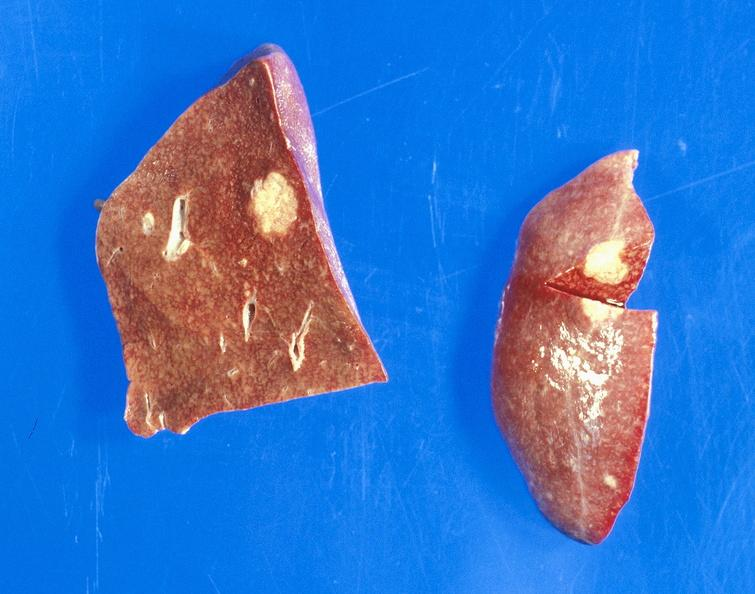what is present?
Answer the question using a single word or phrase. Hepatobiliary 